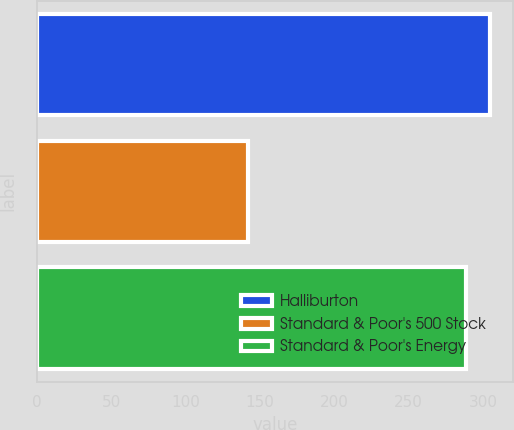Convert chart. <chart><loc_0><loc_0><loc_500><loc_500><bar_chart><fcel>Halliburton<fcel>Standard & Poor's 500 Stock<fcel>Standard & Poor's Energy<nl><fcel>304.79<fcel>142.1<fcel>288.47<nl></chart> 